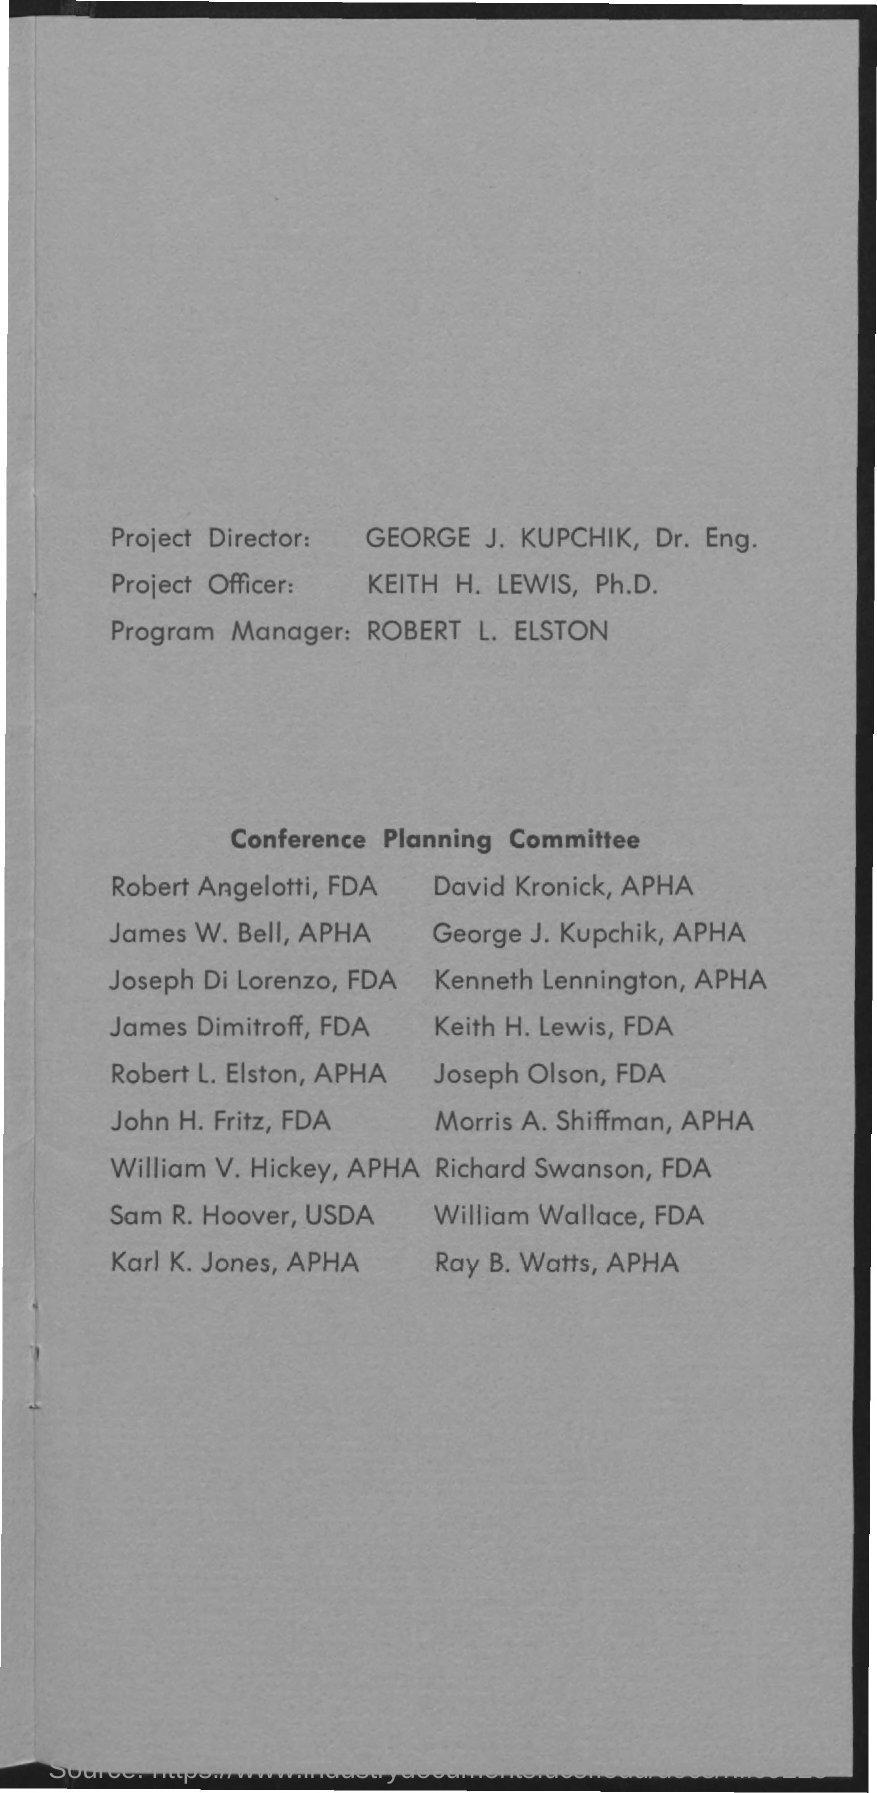Who is the project officer?
Make the answer very short. Keith H. Lewis, Ph.D. Who is the program manager?
Give a very brief answer. ROBERT L. ELSTON. 